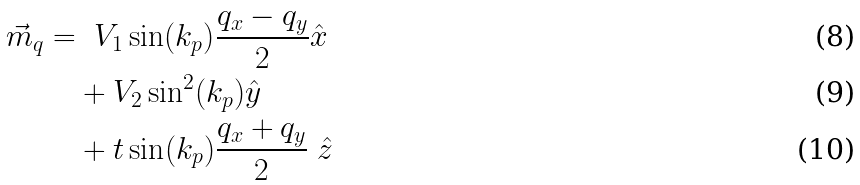<formula> <loc_0><loc_0><loc_500><loc_500>\vec { m } _ { q } = & \ \ V _ { 1 } \sin ( k _ { p } ) \frac { q _ { x } - q _ { y } } { 2 } \hat { x } \\ & + V _ { 2 } \sin ^ { 2 } ( k _ { p } ) \hat { y } \\ & + t \sin ( k _ { p } ) \frac { q _ { x } + q _ { y } } { 2 } \ \hat { z }</formula> 